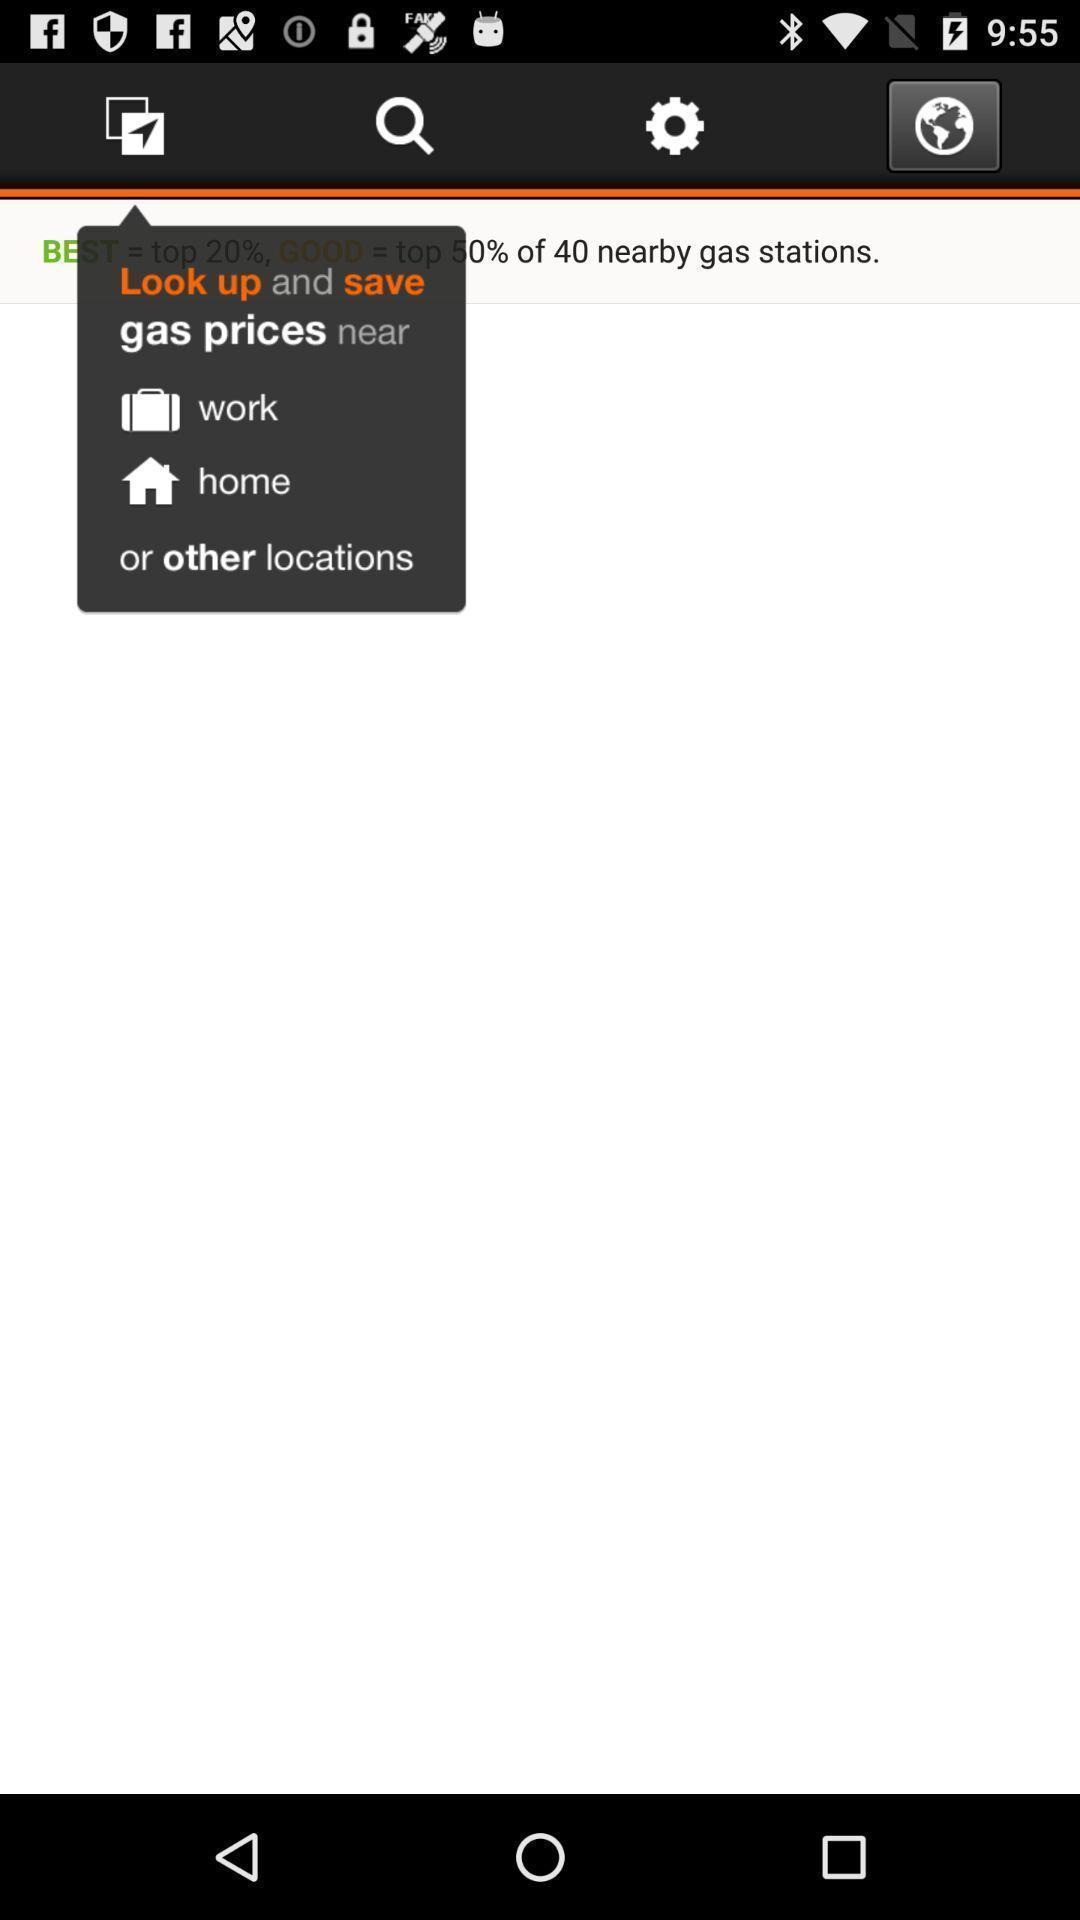Describe the content in this image. Screen displaying the drop down for save option. 